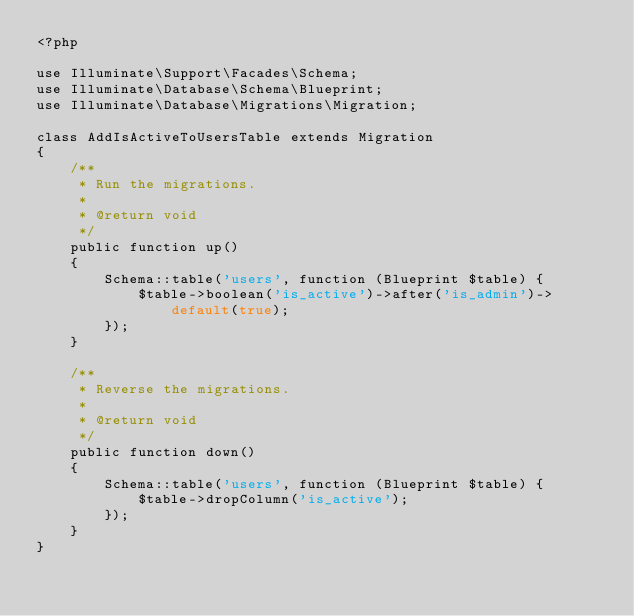<code> <loc_0><loc_0><loc_500><loc_500><_PHP_><?php

use Illuminate\Support\Facades\Schema;
use Illuminate\Database\Schema\Blueprint;
use Illuminate\Database\Migrations\Migration;

class AddIsActiveToUsersTable extends Migration
{
    /**
     * Run the migrations.
     *
     * @return void
     */
    public function up()
    {
        Schema::table('users', function (Blueprint $table) {
            $table->boolean('is_active')->after('is_admin')->default(true);
        });
    }

    /**
     * Reverse the migrations.
     *
     * @return void
     */
    public function down()
    {
        Schema::table('users', function (Blueprint $table) {
            $table->dropColumn('is_active');
        });
    }
}
</code> 